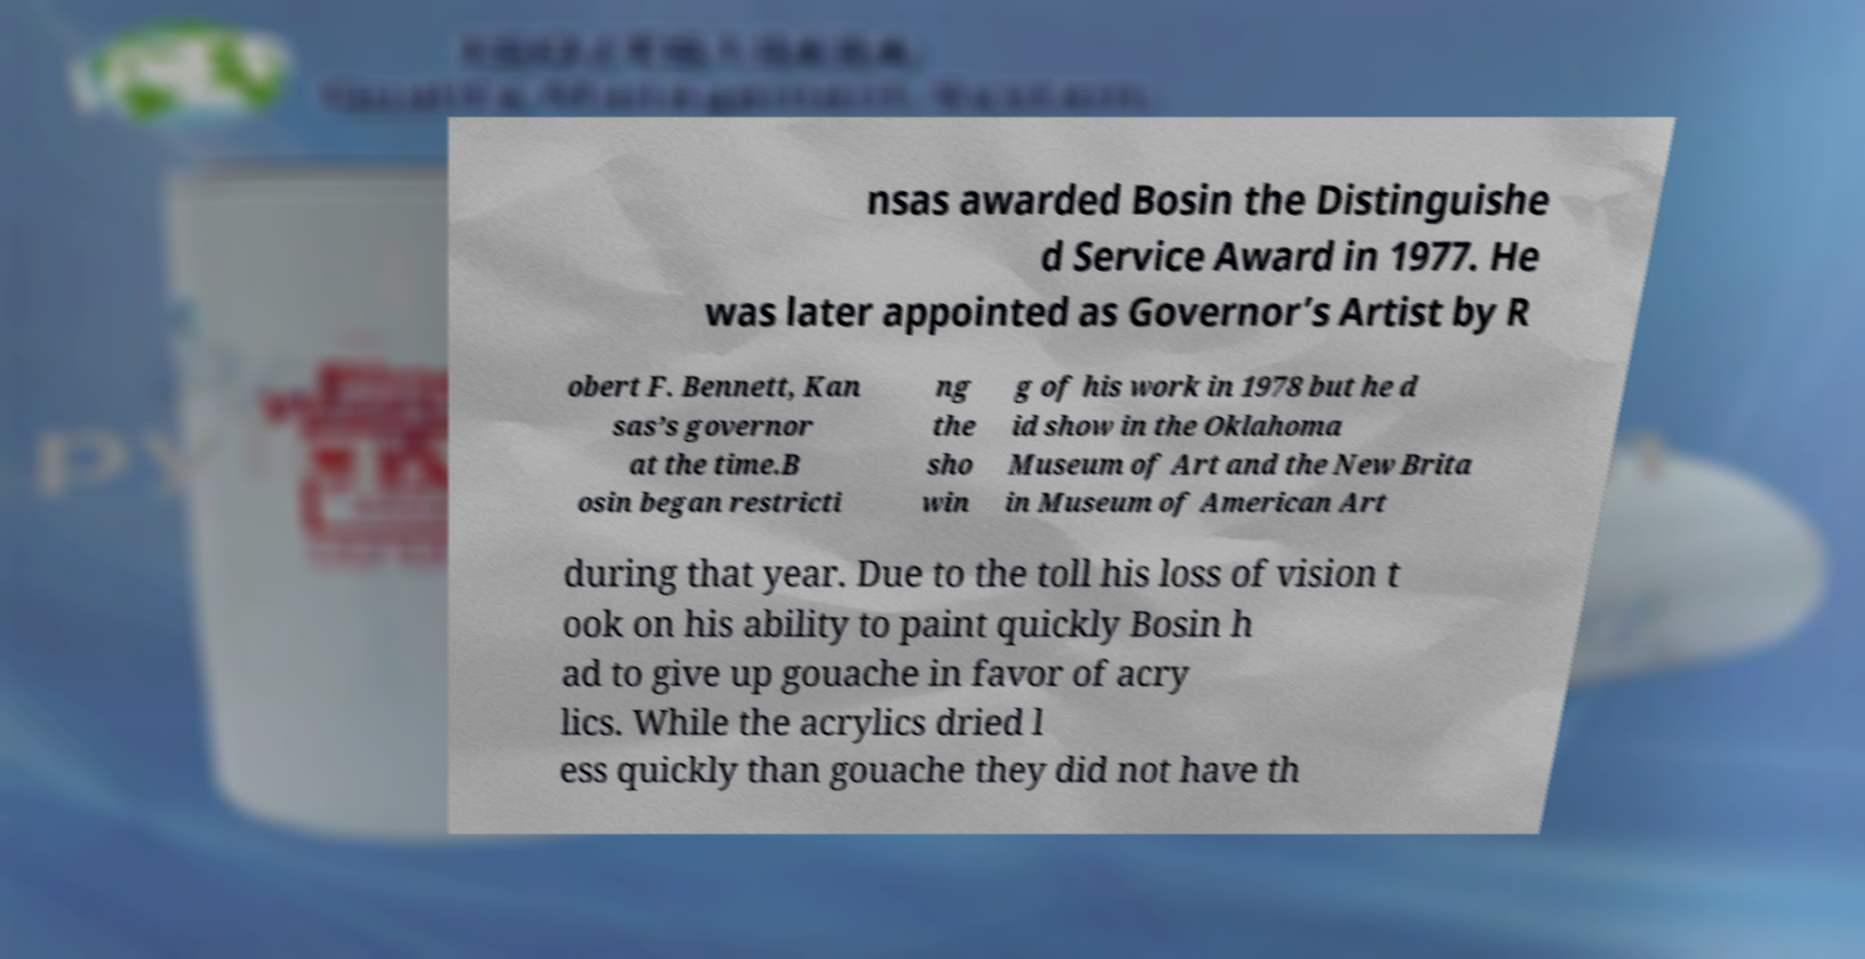Could you extract and type out the text from this image? nsas awarded Bosin the Distinguishe d Service Award in 1977. He was later appointed as Governor’s Artist by R obert F. Bennett, Kan sas’s governor at the time.B osin began restricti ng the sho win g of his work in 1978 but he d id show in the Oklahoma Museum of Art and the New Brita in Museum of American Art during that year. Due to the toll his loss of vision t ook on his ability to paint quickly Bosin h ad to give up gouache in favor of acry lics. While the acrylics dried l ess quickly than gouache they did not have th 